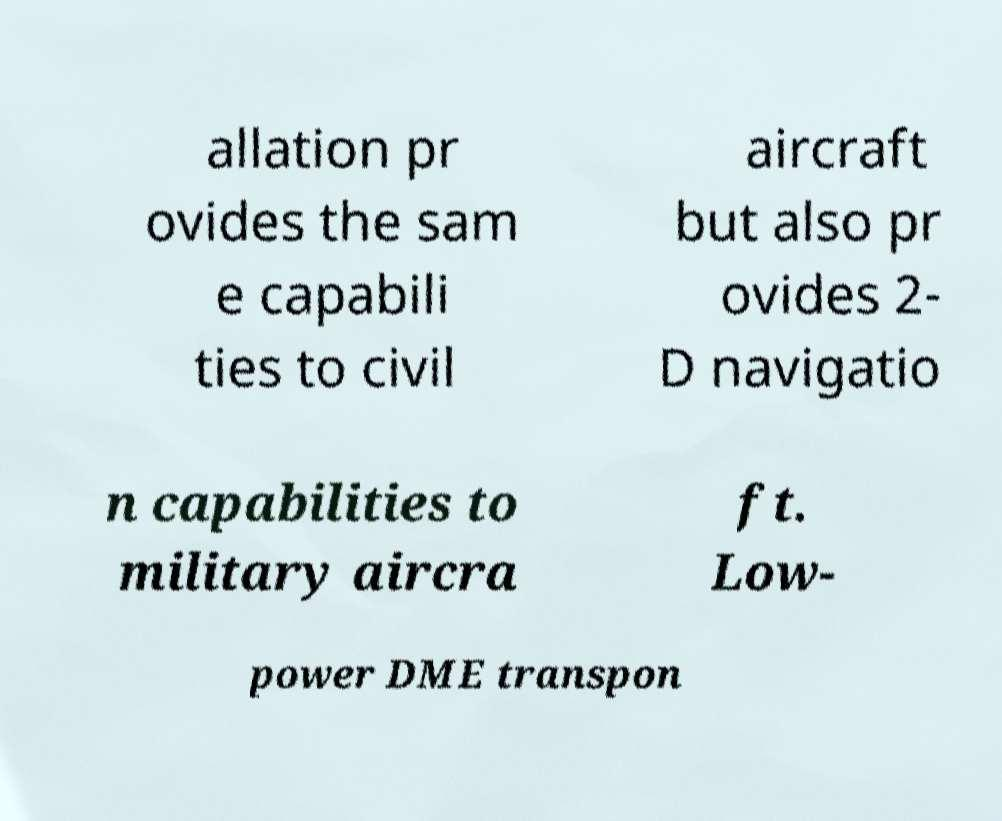What messages or text are displayed in this image? I need them in a readable, typed format. allation pr ovides the sam e capabili ties to civil aircraft but also pr ovides 2- D navigatio n capabilities to military aircra ft. Low- power DME transpon 